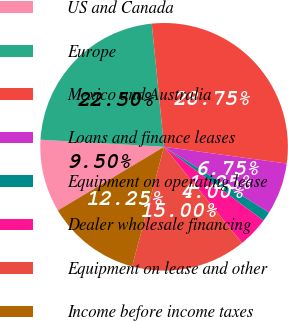Convert chart to OTSL. <chart><loc_0><loc_0><loc_500><loc_500><pie_chart><fcel>US and Canada<fcel>Europe<fcel>Mexico and Australia<fcel>Loans and finance leases<fcel>Equipment on operating lease<fcel>Dealer wholesale financing<fcel>Equipment on lease and other<fcel>Income before income taxes<nl><fcel>9.5%<fcel>22.5%<fcel>28.75%<fcel>6.75%<fcel>1.25%<fcel>4.0%<fcel>15.0%<fcel>12.25%<nl></chart> 